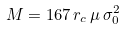<formula> <loc_0><loc_0><loc_500><loc_500>M = 1 6 7 \, r _ { c } \, \mu \, \sigma _ { 0 } ^ { 2 }</formula> 